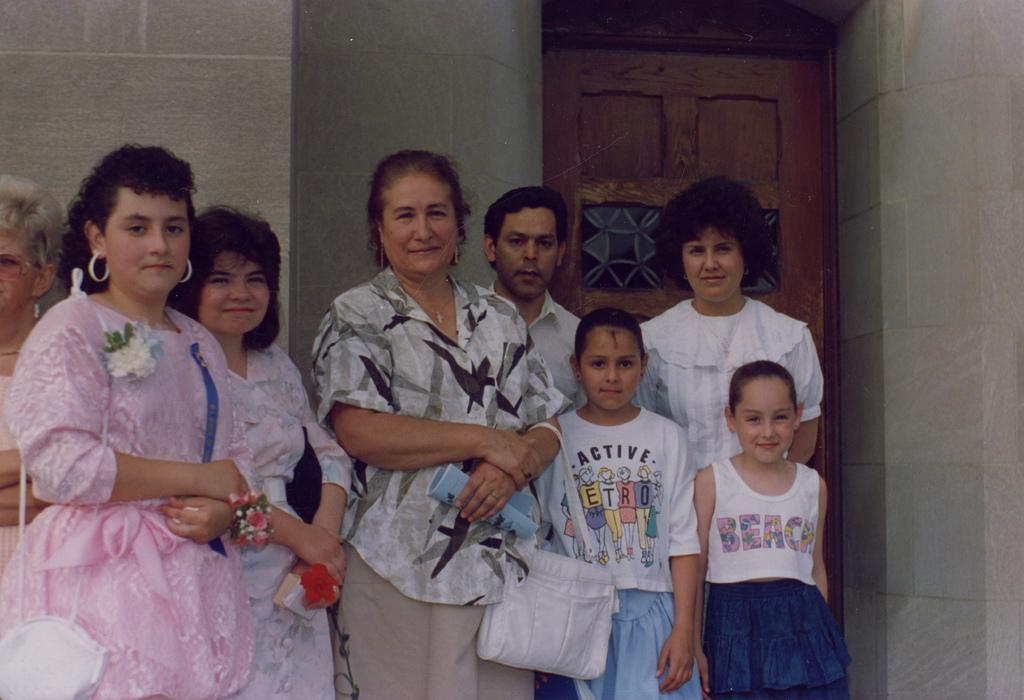How many people are in the image? There is a group of people in the image. What are the people doing in the image? The people are standing and smiling. What objects can be seen in the image besides the people? There are bags in the image. What can be seen in the background of the image? There is a door and walls in the background of the image. What type of ink is being used to write on the curtain in the image? There is no curtain or writing present in the image; it features a group of people standing and smiling with bags, and a door and walls in the background. 